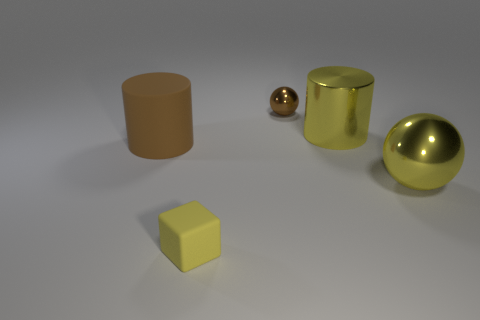Add 1 small yellow rubber cylinders. How many objects exist? 6 Subtract all cylinders. How many objects are left? 3 Subtract all shiny balls. Subtract all large brown rubber things. How many objects are left? 2 Add 2 tiny yellow rubber objects. How many tiny yellow rubber objects are left? 3 Add 1 large brown rubber cylinders. How many large brown rubber cylinders exist? 2 Subtract 0 green cylinders. How many objects are left? 5 